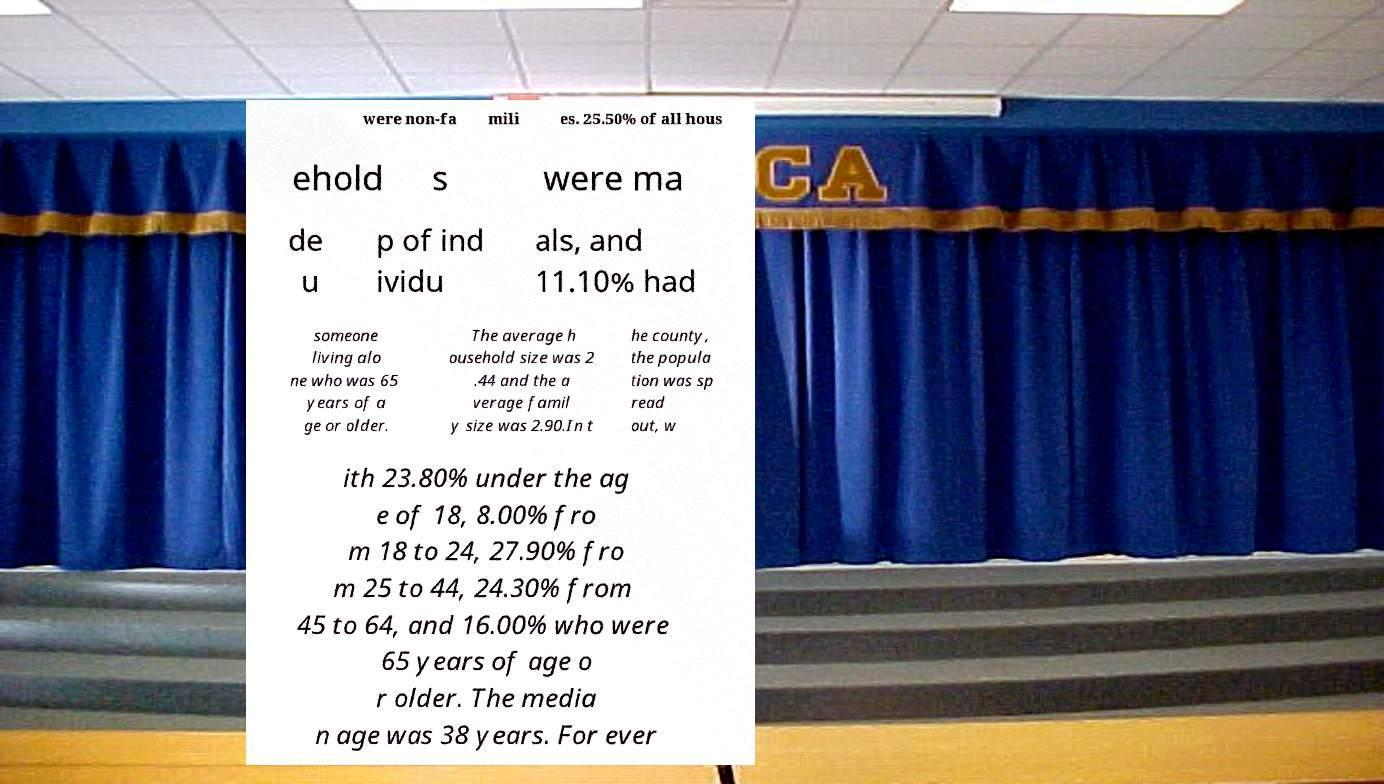Could you assist in decoding the text presented in this image and type it out clearly? were non-fa mili es. 25.50% of all hous ehold s were ma de u p of ind ividu als, and 11.10% had someone living alo ne who was 65 years of a ge or older. The average h ousehold size was 2 .44 and the a verage famil y size was 2.90.In t he county, the popula tion was sp read out, w ith 23.80% under the ag e of 18, 8.00% fro m 18 to 24, 27.90% fro m 25 to 44, 24.30% from 45 to 64, and 16.00% who were 65 years of age o r older. The media n age was 38 years. For ever 